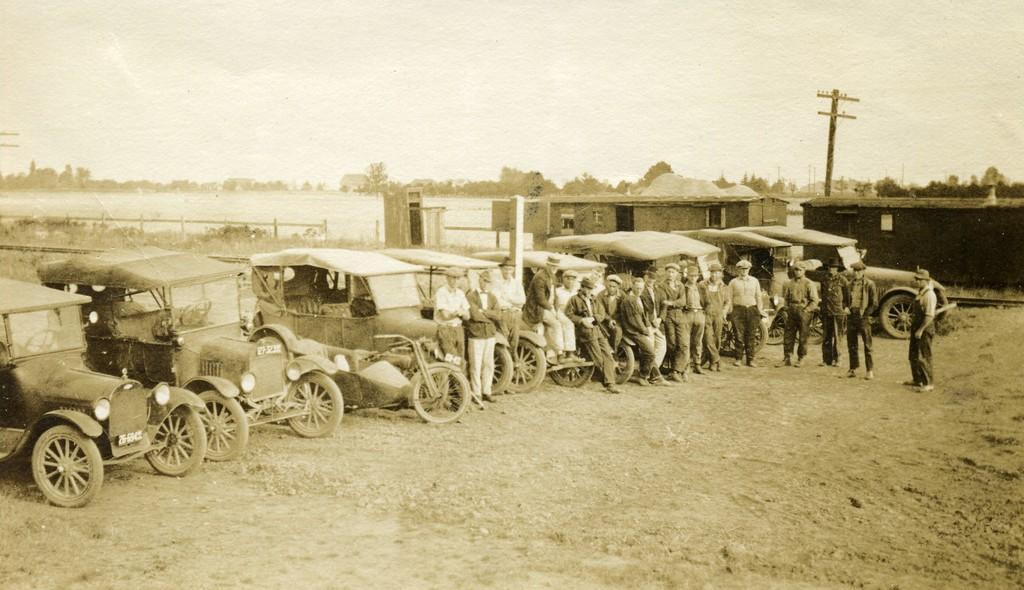Describe this image in one or two sentences. This is an very old picture, in the image, in the middle, there are vehicles, in front of the vehicles, few people standing, behind the vehicle,may be there is the lake , train , poles, trees visible, at the top there is the sky. 